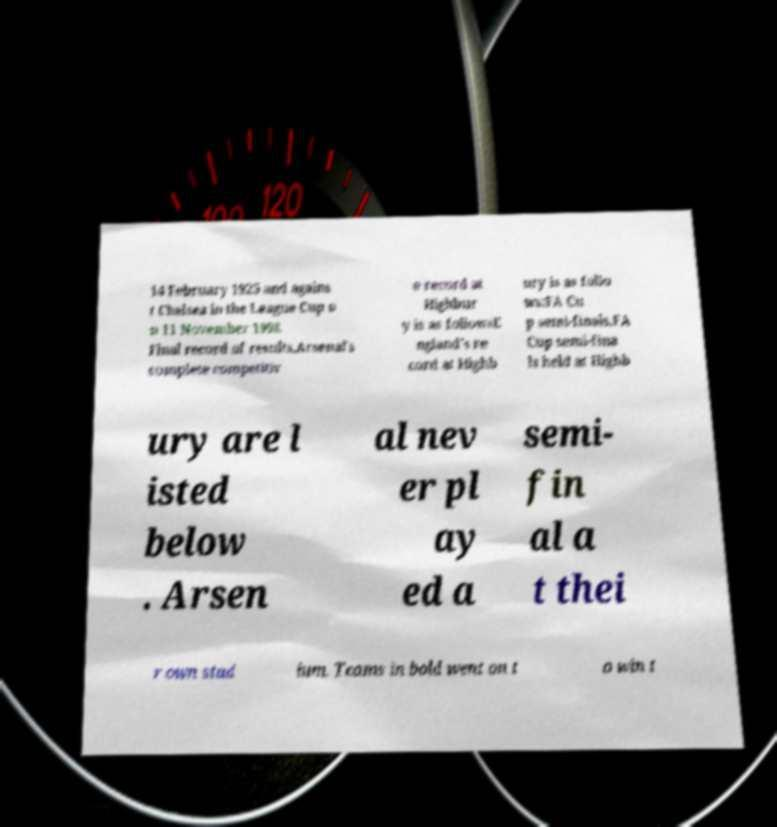I need the written content from this picture converted into text. Can you do that? 14 February 1925 and agains t Chelsea in the League Cup o n 11 November 1998. Final record of results.Arsenal's complete competitiv e record at Highbur y is as followsE ngland's re cord at Highb ury is as follo ws:FA Cu p semi-finals.FA Cup semi-fina ls held at Highb ury are l isted below . Arsen al nev er pl ay ed a semi- fin al a t thei r own stad ium. Teams in bold went on t o win t 